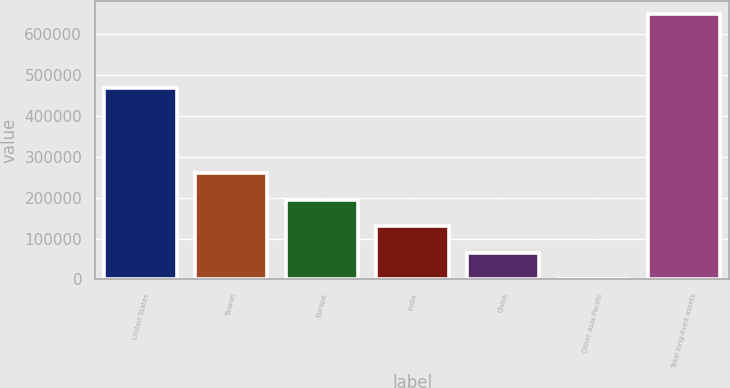<chart> <loc_0><loc_0><loc_500><loc_500><bar_chart><fcel>United States<fcel>Taiwan<fcel>Europe<fcel>India<fcel>China<fcel>Other Asia Pacific<fcel>Total long-lived assets<nl><fcel>467277<fcel>259623<fcel>194864<fcel>130105<fcel>65346.1<fcel>587<fcel>648178<nl></chart> 